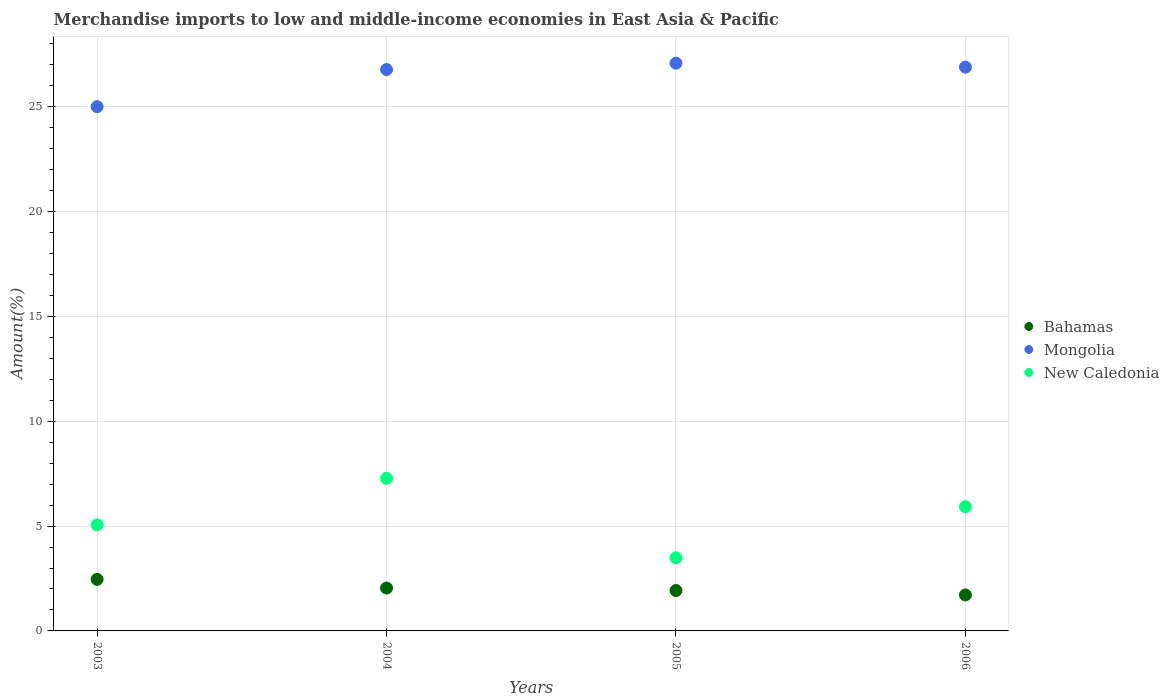How many different coloured dotlines are there?
Make the answer very short. 3. Is the number of dotlines equal to the number of legend labels?
Offer a terse response. Yes. What is the percentage of amount earned from merchandise imports in Mongolia in 2005?
Give a very brief answer. 27.08. Across all years, what is the maximum percentage of amount earned from merchandise imports in Bahamas?
Ensure brevity in your answer.  2.46. Across all years, what is the minimum percentage of amount earned from merchandise imports in Mongolia?
Offer a terse response. 25. In which year was the percentage of amount earned from merchandise imports in Bahamas maximum?
Keep it short and to the point. 2003. In which year was the percentage of amount earned from merchandise imports in Mongolia minimum?
Your answer should be compact. 2003. What is the total percentage of amount earned from merchandise imports in Mongolia in the graph?
Keep it short and to the point. 105.75. What is the difference between the percentage of amount earned from merchandise imports in New Caledonia in 2003 and that in 2005?
Make the answer very short. 1.57. What is the difference between the percentage of amount earned from merchandise imports in Bahamas in 2004 and the percentage of amount earned from merchandise imports in New Caledonia in 2003?
Give a very brief answer. -3.01. What is the average percentage of amount earned from merchandise imports in Mongolia per year?
Your answer should be compact. 26.44. In the year 2004, what is the difference between the percentage of amount earned from merchandise imports in Bahamas and percentage of amount earned from merchandise imports in Mongolia?
Your answer should be compact. -24.73. What is the ratio of the percentage of amount earned from merchandise imports in New Caledonia in 2005 to that in 2006?
Your response must be concise. 0.59. Is the difference between the percentage of amount earned from merchandise imports in Bahamas in 2003 and 2005 greater than the difference between the percentage of amount earned from merchandise imports in Mongolia in 2003 and 2005?
Offer a very short reply. Yes. What is the difference between the highest and the second highest percentage of amount earned from merchandise imports in Bahamas?
Ensure brevity in your answer.  0.41. What is the difference between the highest and the lowest percentage of amount earned from merchandise imports in New Caledonia?
Your response must be concise. 3.79. In how many years, is the percentage of amount earned from merchandise imports in New Caledonia greater than the average percentage of amount earned from merchandise imports in New Caledonia taken over all years?
Make the answer very short. 2. Is the sum of the percentage of amount earned from merchandise imports in Mongolia in 2004 and 2006 greater than the maximum percentage of amount earned from merchandise imports in New Caledonia across all years?
Give a very brief answer. Yes. Is it the case that in every year, the sum of the percentage of amount earned from merchandise imports in Bahamas and percentage of amount earned from merchandise imports in Mongolia  is greater than the percentage of amount earned from merchandise imports in New Caledonia?
Provide a succinct answer. Yes. Does the percentage of amount earned from merchandise imports in Bahamas monotonically increase over the years?
Your answer should be very brief. No. How many years are there in the graph?
Keep it short and to the point. 4. What is the difference between two consecutive major ticks on the Y-axis?
Your answer should be compact. 5. Does the graph contain any zero values?
Your response must be concise. No. Does the graph contain grids?
Make the answer very short. Yes. Where does the legend appear in the graph?
Your response must be concise. Center right. How many legend labels are there?
Offer a terse response. 3. How are the legend labels stacked?
Give a very brief answer. Vertical. What is the title of the graph?
Make the answer very short. Merchandise imports to low and middle-income economies in East Asia & Pacific. What is the label or title of the X-axis?
Your answer should be very brief. Years. What is the label or title of the Y-axis?
Make the answer very short. Amount(%). What is the Amount(%) of Bahamas in 2003?
Give a very brief answer. 2.46. What is the Amount(%) in Mongolia in 2003?
Give a very brief answer. 25. What is the Amount(%) of New Caledonia in 2003?
Give a very brief answer. 5.06. What is the Amount(%) of Bahamas in 2004?
Your answer should be very brief. 2.04. What is the Amount(%) in Mongolia in 2004?
Give a very brief answer. 26.78. What is the Amount(%) of New Caledonia in 2004?
Offer a terse response. 7.28. What is the Amount(%) of Bahamas in 2005?
Your response must be concise. 1.93. What is the Amount(%) of Mongolia in 2005?
Keep it short and to the point. 27.08. What is the Amount(%) in New Caledonia in 2005?
Ensure brevity in your answer.  3.49. What is the Amount(%) of Bahamas in 2006?
Ensure brevity in your answer.  1.72. What is the Amount(%) of Mongolia in 2006?
Give a very brief answer. 26.89. What is the Amount(%) in New Caledonia in 2006?
Provide a short and direct response. 5.93. Across all years, what is the maximum Amount(%) in Bahamas?
Provide a succinct answer. 2.46. Across all years, what is the maximum Amount(%) of Mongolia?
Your answer should be very brief. 27.08. Across all years, what is the maximum Amount(%) in New Caledonia?
Make the answer very short. 7.28. Across all years, what is the minimum Amount(%) in Bahamas?
Offer a very short reply. 1.72. Across all years, what is the minimum Amount(%) of Mongolia?
Give a very brief answer. 25. Across all years, what is the minimum Amount(%) of New Caledonia?
Your response must be concise. 3.49. What is the total Amount(%) in Bahamas in the graph?
Provide a succinct answer. 8.15. What is the total Amount(%) in Mongolia in the graph?
Make the answer very short. 105.75. What is the total Amount(%) of New Caledonia in the graph?
Your answer should be compact. 21.75. What is the difference between the Amount(%) of Bahamas in 2003 and that in 2004?
Ensure brevity in your answer.  0.41. What is the difference between the Amount(%) in Mongolia in 2003 and that in 2004?
Offer a terse response. -1.77. What is the difference between the Amount(%) of New Caledonia in 2003 and that in 2004?
Offer a very short reply. -2.22. What is the difference between the Amount(%) in Bahamas in 2003 and that in 2005?
Offer a very short reply. 0.53. What is the difference between the Amount(%) of Mongolia in 2003 and that in 2005?
Make the answer very short. -2.08. What is the difference between the Amount(%) in New Caledonia in 2003 and that in 2005?
Your answer should be very brief. 1.57. What is the difference between the Amount(%) in Bahamas in 2003 and that in 2006?
Your answer should be very brief. 0.74. What is the difference between the Amount(%) of Mongolia in 2003 and that in 2006?
Ensure brevity in your answer.  -1.89. What is the difference between the Amount(%) in New Caledonia in 2003 and that in 2006?
Your answer should be very brief. -0.87. What is the difference between the Amount(%) of Bahamas in 2004 and that in 2005?
Your response must be concise. 0.12. What is the difference between the Amount(%) of Mongolia in 2004 and that in 2005?
Make the answer very short. -0.3. What is the difference between the Amount(%) of New Caledonia in 2004 and that in 2005?
Offer a terse response. 3.79. What is the difference between the Amount(%) in Bahamas in 2004 and that in 2006?
Your answer should be very brief. 0.33. What is the difference between the Amount(%) of Mongolia in 2004 and that in 2006?
Ensure brevity in your answer.  -0.11. What is the difference between the Amount(%) of New Caledonia in 2004 and that in 2006?
Your response must be concise. 1.35. What is the difference between the Amount(%) of Bahamas in 2005 and that in 2006?
Provide a succinct answer. 0.21. What is the difference between the Amount(%) in Mongolia in 2005 and that in 2006?
Your answer should be very brief. 0.19. What is the difference between the Amount(%) in New Caledonia in 2005 and that in 2006?
Provide a short and direct response. -2.44. What is the difference between the Amount(%) of Bahamas in 2003 and the Amount(%) of Mongolia in 2004?
Provide a short and direct response. -24.32. What is the difference between the Amount(%) of Bahamas in 2003 and the Amount(%) of New Caledonia in 2004?
Ensure brevity in your answer.  -4.82. What is the difference between the Amount(%) of Mongolia in 2003 and the Amount(%) of New Caledonia in 2004?
Keep it short and to the point. 17.73. What is the difference between the Amount(%) in Bahamas in 2003 and the Amount(%) in Mongolia in 2005?
Provide a short and direct response. -24.62. What is the difference between the Amount(%) of Bahamas in 2003 and the Amount(%) of New Caledonia in 2005?
Ensure brevity in your answer.  -1.03. What is the difference between the Amount(%) in Mongolia in 2003 and the Amount(%) in New Caledonia in 2005?
Your answer should be very brief. 21.51. What is the difference between the Amount(%) in Bahamas in 2003 and the Amount(%) in Mongolia in 2006?
Make the answer very short. -24.43. What is the difference between the Amount(%) in Bahamas in 2003 and the Amount(%) in New Caledonia in 2006?
Provide a succinct answer. -3.47. What is the difference between the Amount(%) of Mongolia in 2003 and the Amount(%) of New Caledonia in 2006?
Offer a very short reply. 19.08. What is the difference between the Amount(%) in Bahamas in 2004 and the Amount(%) in Mongolia in 2005?
Your answer should be compact. -25.04. What is the difference between the Amount(%) of Bahamas in 2004 and the Amount(%) of New Caledonia in 2005?
Provide a succinct answer. -1.45. What is the difference between the Amount(%) in Mongolia in 2004 and the Amount(%) in New Caledonia in 2005?
Give a very brief answer. 23.28. What is the difference between the Amount(%) in Bahamas in 2004 and the Amount(%) in Mongolia in 2006?
Offer a terse response. -24.85. What is the difference between the Amount(%) of Bahamas in 2004 and the Amount(%) of New Caledonia in 2006?
Your answer should be very brief. -3.88. What is the difference between the Amount(%) of Mongolia in 2004 and the Amount(%) of New Caledonia in 2006?
Provide a succinct answer. 20.85. What is the difference between the Amount(%) of Bahamas in 2005 and the Amount(%) of Mongolia in 2006?
Your response must be concise. -24.96. What is the difference between the Amount(%) of Bahamas in 2005 and the Amount(%) of New Caledonia in 2006?
Provide a succinct answer. -4. What is the difference between the Amount(%) of Mongolia in 2005 and the Amount(%) of New Caledonia in 2006?
Keep it short and to the point. 21.15. What is the average Amount(%) of Bahamas per year?
Offer a terse response. 2.04. What is the average Amount(%) of Mongolia per year?
Make the answer very short. 26.44. What is the average Amount(%) in New Caledonia per year?
Keep it short and to the point. 5.44. In the year 2003, what is the difference between the Amount(%) of Bahamas and Amount(%) of Mongolia?
Provide a succinct answer. -22.55. In the year 2003, what is the difference between the Amount(%) in Bahamas and Amount(%) in New Caledonia?
Your answer should be compact. -2.6. In the year 2003, what is the difference between the Amount(%) in Mongolia and Amount(%) in New Caledonia?
Give a very brief answer. 19.94. In the year 2004, what is the difference between the Amount(%) of Bahamas and Amount(%) of Mongolia?
Give a very brief answer. -24.73. In the year 2004, what is the difference between the Amount(%) in Bahamas and Amount(%) in New Caledonia?
Your answer should be very brief. -5.23. In the year 2004, what is the difference between the Amount(%) in Mongolia and Amount(%) in New Caledonia?
Your answer should be very brief. 19.5. In the year 2005, what is the difference between the Amount(%) of Bahamas and Amount(%) of Mongolia?
Keep it short and to the point. -25.15. In the year 2005, what is the difference between the Amount(%) of Bahamas and Amount(%) of New Caledonia?
Offer a terse response. -1.56. In the year 2005, what is the difference between the Amount(%) in Mongolia and Amount(%) in New Caledonia?
Offer a very short reply. 23.59. In the year 2006, what is the difference between the Amount(%) of Bahamas and Amount(%) of Mongolia?
Your answer should be very brief. -25.17. In the year 2006, what is the difference between the Amount(%) of Bahamas and Amount(%) of New Caledonia?
Your answer should be very brief. -4.21. In the year 2006, what is the difference between the Amount(%) in Mongolia and Amount(%) in New Caledonia?
Offer a very short reply. 20.96. What is the ratio of the Amount(%) in Bahamas in 2003 to that in 2004?
Your response must be concise. 1.2. What is the ratio of the Amount(%) in Mongolia in 2003 to that in 2004?
Provide a succinct answer. 0.93. What is the ratio of the Amount(%) of New Caledonia in 2003 to that in 2004?
Your answer should be very brief. 0.7. What is the ratio of the Amount(%) in Bahamas in 2003 to that in 2005?
Offer a very short reply. 1.28. What is the ratio of the Amount(%) of Mongolia in 2003 to that in 2005?
Keep it short and to the point. 0.92. What is the ratio of the Amount(%) of New Caledonia in 2003 to that in 2005?
Keep it short and to the point. 1.45. What is the ratio of the Amount(%) of Bahamas in 2003 to that in 2006?
Your response must be concise. 1.43. What is the ratio of the Amount(%) of Mongolia in 2003 to that in 2006?
Your answer should be very brief. 0.93. What is the ratio of the Amount(%) of New Caledonia in 2003 to that in 2006?
Your answer should be compact. 0.85. What is the ratio of the Amount(%) in Bahamas in 2004 to that in 2005?
Your answer should be very brief. 1.06. What is the ratio of the Amount(%) in Mongolia in 2004 to that in 2005?
Your answer should be compact. 0.99. What is the ratio of the Amount(%) in New Caledonia in 2004 to that in 2005?
Offer a terse response. 2.08. What is the ratio of the Amount(%) of Bahamas in 2004 to that in 2006?
Your answer should be compact. 1.19. What is the ratio of the Amount(%) of Mongolia in 2004 to that in 2006?
Your answer should be compact. 1. What is the ratio of the Amount(%) in New Caledonia in 2004 to that in 2006?
Make the answer very short. 1.23. What is the ratio of the Amount(%) of Bahamas in 2005 to that in 2006?
Provide a short and direct response. 1.12. What is the ratio of the Amount(%) of Mongolia in 2005 to that in 2006?
Your answer should be very brief. 1.01. What is the ratio of the Amount(%) of New Caledonia in 2005 to that in 2006?
Make the answer very short. 0.59. What is the difference between the highest and the second highest Amount(%) of Bahamas?
Provide a succinct answer. 0.41. What is the difference between the highest and the second highest Amount(%) in Mongolia?
Ensure brevity in your answer.  0.19. What is the difference between the highest and the second highest Amount(%) of New Caledonia?
Provide a succinct answer. 1.35. What is the difference between the highest and the lowest Amount(%) of Bahamas?
Provide a succinct answer. 0.74. What is the difference between the highest and the lowest Amount(%) of Mongolia?
Provide a succinct answer. 2.08. What is the difference between the highest and the lowest Amount(%) of New Caledonia?
Provide a short and direct response. 3.79. 